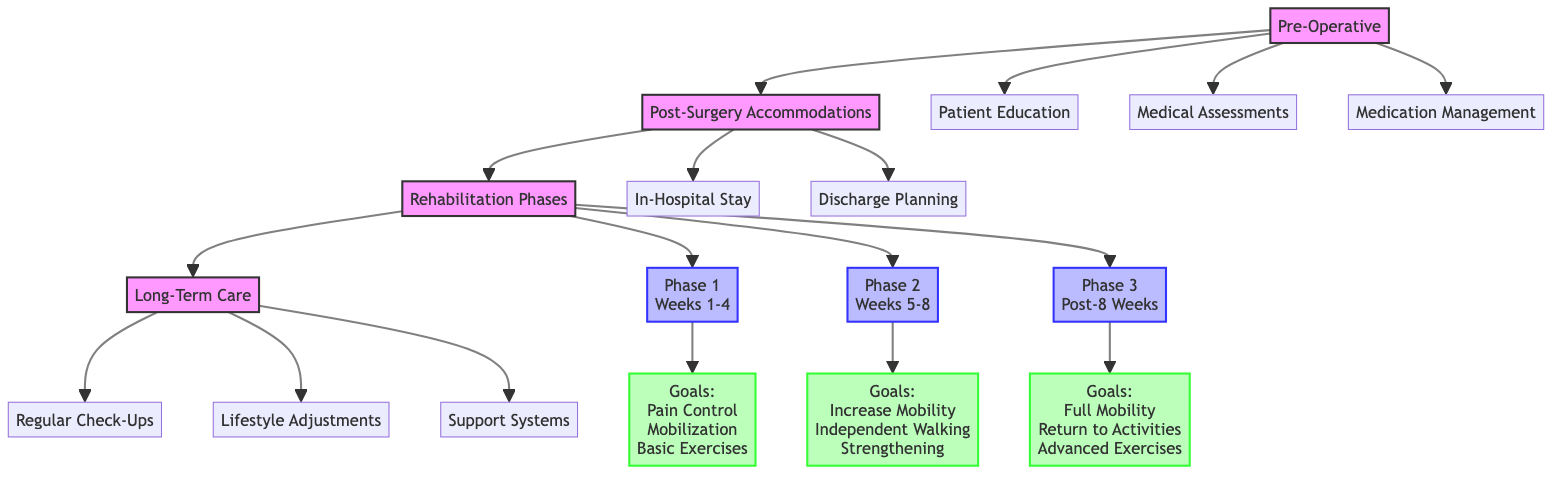What are the three main categories before the surgery? The diagram illustrates three categories under "Pre-Operative": "Patient Education," "Medical Assessments," and "Medication Management." These categories represent the necessary steps to prepare a patient for surgery.
Answer: Patient Education, Medical Assessments, Medication Management How many phases of rehabilitation are shown? The diagram indicates three distinct phases of rehabilitation under "Rehabilitation Phases": Phase 1 (Weeks 1-4), Phase 2 (Weeks 5-8), and Phase 3 (Post-8 Weeks), meaning there are a total of three phases.
Answer: 3 What is a goal of Phase 2? In the second phase of rehabilitation, one of the listed goals is "Independent Walking with Aid," which exemplifies the focus on increasing mobility during this stage.
Answer: Independent Walking with Aid What is the first item listed under Long-Term Care? The diagram outlines three elements under "Long-Term Care" and indicates "Regular Check-Ups" as the first item, which emphasizes the importance of ongoing monitoring following surgery.
Answer: Regular Check-Ups Which phase focuses on pain control? According to the diagram, "Pain Control" is one of the goals listed under Phase 1 (Weeks 1-4), highlighting its significance in the initial rehabilitation phase.
Answer: Phase 1 What are the two activities included in Post-Surgery Accommodations? The diagram demonstrates two primary activities under "Post-Surgery Accommodations": "In-Hospital Stay" and "Discharge Planning," which outlines the necessary steps for patient recovery and transition.
Answer: In-Hospital Stay, Discharge Planning Which rehabilitation phase includes hydrotherapy sessions? "Hydrotherapy Sessions" are specifically mentioned as a key activity in Phase 2 (Weeks 5-8), indicating a focus on enhancing mobility and recovery during this period.
Answer: Phase 2 What category comes after Post-Surgery Accommodations? The flowchart indicates that the next category following "Post-Surgery Accommodations" is "Rehabilitation Phases," suggesting a progression from initial recovery to structured rehabilitation.
Answer: Rehabilitation Phases What goal is associated with the final phase of rehabilitation? The final phase, which is Phase 3 (Post-8 Weeks), includes the goal of "Return to Daily Activities," indicating a focus on reintegrating patients into their normal routines.
Answer: Return to Daily Activities 